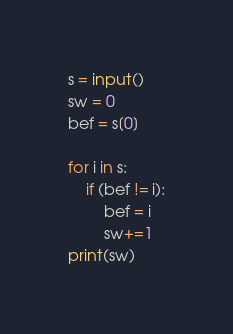<code> <loc_0><loc_0><loc_500><loc_500><_Python_>s = input()
sw = 0
bef = s[0]

for i in s:
    if (bef != i):
        bef = i
        sw+=1
print(sw)</code> 